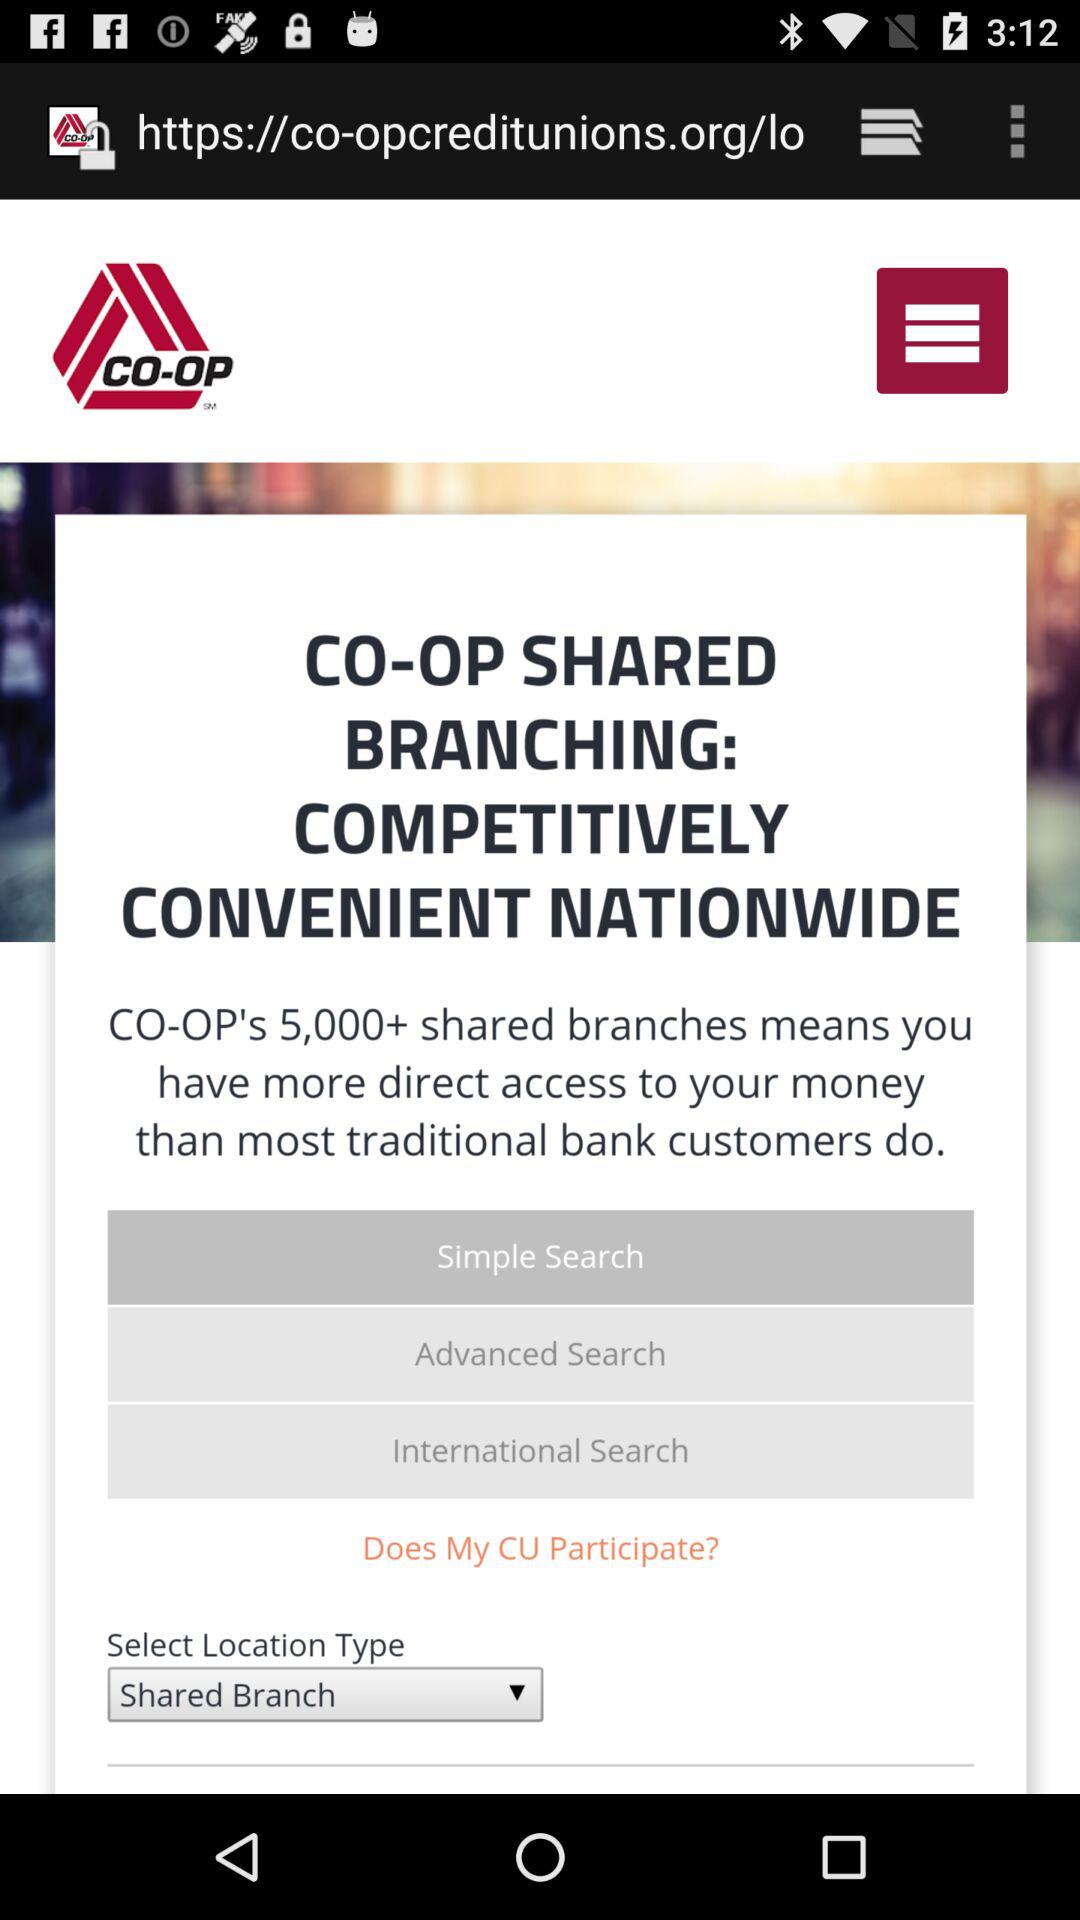What location type is selected? The selected location type is "Shared Branch". 